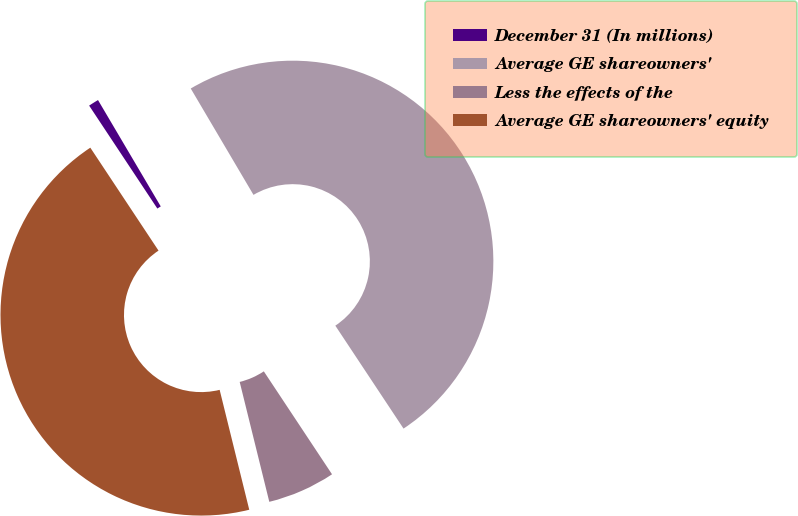<chart> <loc_0><loc_0><loc_500><loc_500><pie_chart><fcel>December 31 (In millions)<fcel>Average GE shareowners'<fcel>Less the effects of the<fcel>Average GE shareowners' equity<nl><fcel>0.83%<fcel>49.17%<fcel>5.46%<fcel>44.54%<nl></chart> 